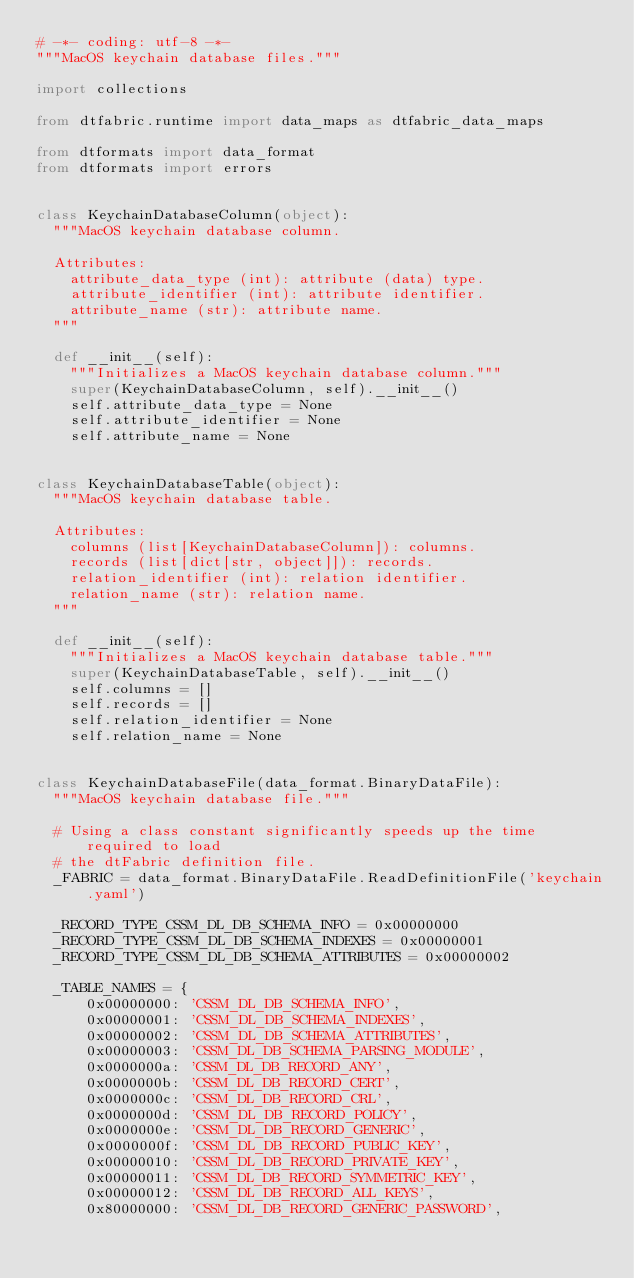Convert code to text. <code><loc_0><loc_0><loc_500><loc_500><_Python_># -*- coding: utf-8 -*-
"""MacOS keychain database files."""

import collections

from dtfabric.runtime import data_maps as dtfabric_data_maps

from dtformats import data_format
from dtformats import errors


class KeychainDatabaseColumn(object):
  """MacOS keychain database column.

  Attributes:
    attribute_data_type (int): attribute (data) type.
    attribute_identifier (int): attribute identifier.
    attribute_name (str): attribute name.
  """

  def __init__(self):
    """Initializes a MacOS keychain database column."""
    super(KeychainDatabaseColumn, self).__init__()
    self.attribute_data_type = None
    self.attribute_identifier = None
    self.attribute_name = None


class KeychainDatabaseTable(object):
  """MacOS keychain database table.

  Attributes:
    columns (list[KeychainDatabaseColumn]): columns.
    records (list[dict[str, object]]): records.
    relation_identifier (int): relation identifier.
    relation_name (str): relation name.
  """

  def __init__(self):
    """Initializes a MacOS keychain database table."""
    super(KeychainDatabaseTable, self).__init__()
    self.columns = []
    self.records = []
    self.relation_identifier = None
    self.relation_name = None


class KeychainDatabaseFile(data_format.BinaryDataFile):
  """MacOS keychain database file."""

  # Using a class constant significantly speeds up the time required to load
  # the dtFabric definition file.
  _FABRIC = data_format.BinaryDataFile.ReadDefinitionFile('keychain.yaml')

  _RECORD_TYPE_CSSM_DL_DB_SCHEMA_INFO = 0x00000000
  _RECORD_TYPE_CSSM_DL_DB_SCHEMA_INDEXES = 0x00000001
  _RECORD_TYPE_CSSM_DL_DB_SCHEMA_ATTRIBUTES = 0x00000002

  _TABLE_NAMES = {
      0x00000000: 'CSSM_DL_DB_SCHEMA_INFO',
      0x00000001: 'CSSM_DL_DB_SCHEMA_INDEXES',
      0x00000002: 'CSSM_DL_DB_SCHEMA_ATTRIBUTES',
      0x00000003: 'CSSM_DL_DB_SCHEMA_PARSING_MODULE',
      0x0000000a: 'CSSM_DL_DB_RECORD_ANY',
      0x0000000b: 'CSSM_DL_DB_RECORD_CERT',
      0x0000000c: 'CSSM_DL_DB_RECORD_CRL',
      0x0000000d: 'CSSM_DL_DB_RECORD_POLICY',
      0x0000000e: 'CSSM_DL_DB_RECORD_GENERIC',
      0x0000000f: 'CSSM_DL_DB_RECORD_PUBLIC_KEY',
      0x00000010: 'CSSM_DL_DB_RECORD_PRIVATE_KEY',
      0x00000011: 'CSSM_DL_DB_RECORD_SYMMETRIC_KEY',
      0x00000012: 'CSSM_DL_DB_RECORD_ALL_KEYS',
      0x80000000: 'CSSM_DL_DB_RECORD_GENERIC_PASSWORD',</code> 